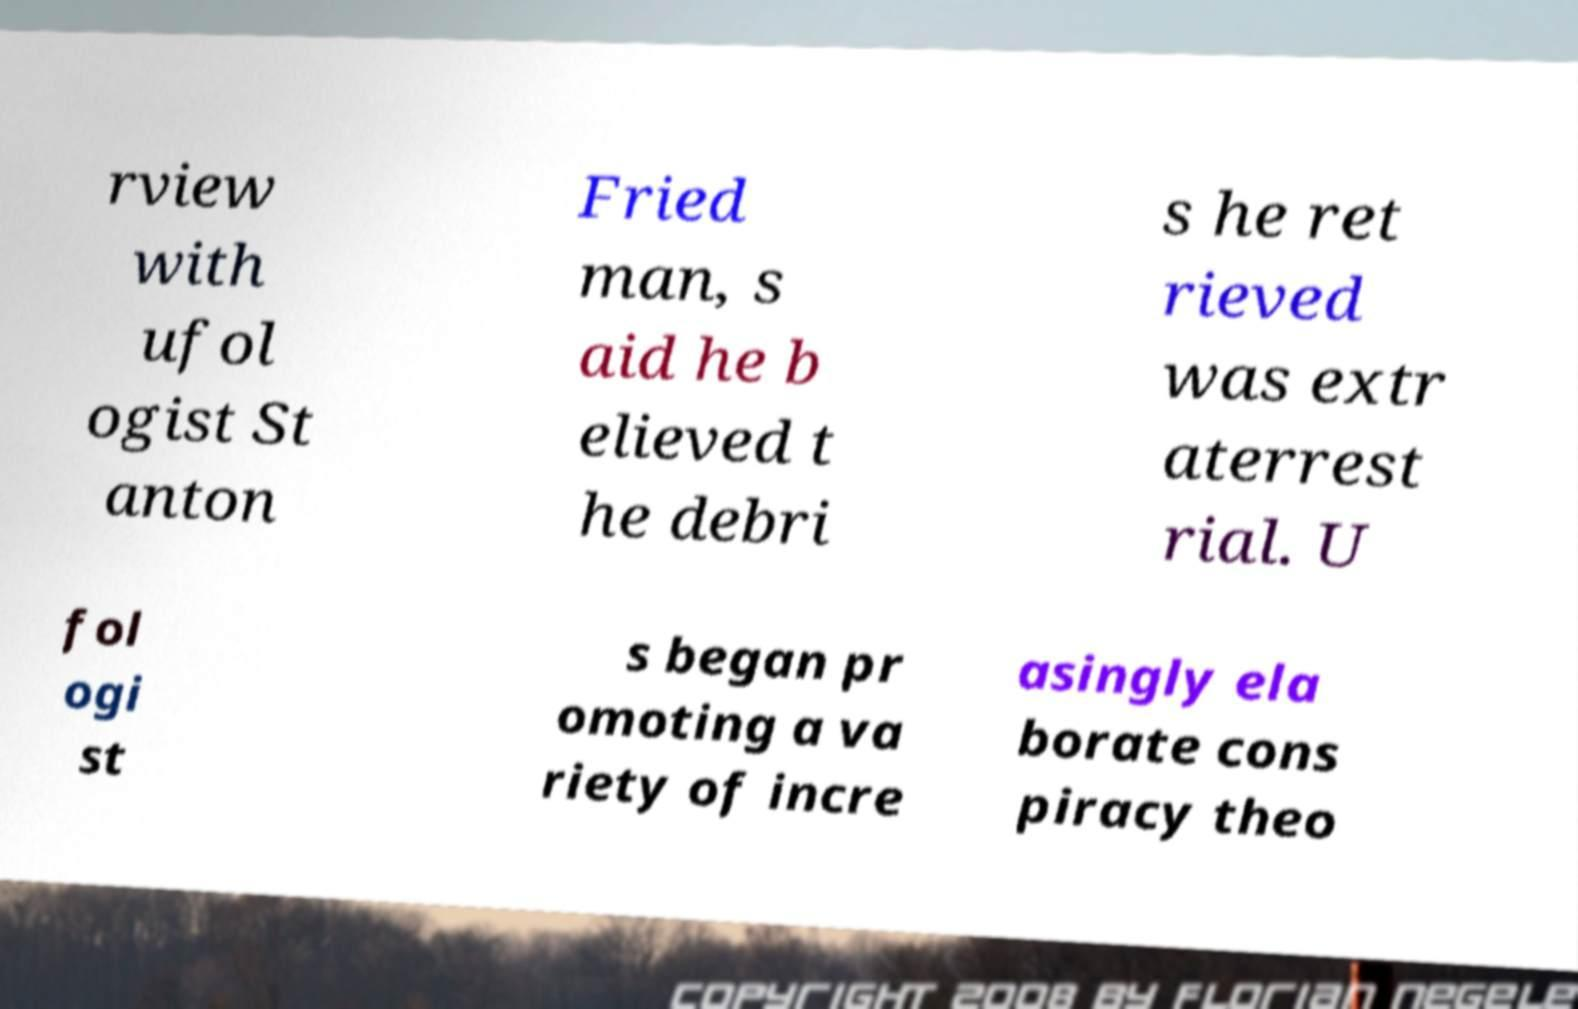There's text embedded in this image that I need extracted. Can you transcribe it verbatim? rview with ufol ogist St anton Fried man, s aid he b elieved t he debri s he ret rieved was extr aterrest rial. U fol ogi st s began pr omoting a va riety of incre asingly ela borate cons piracy theo 